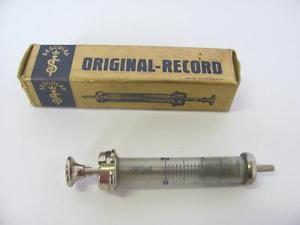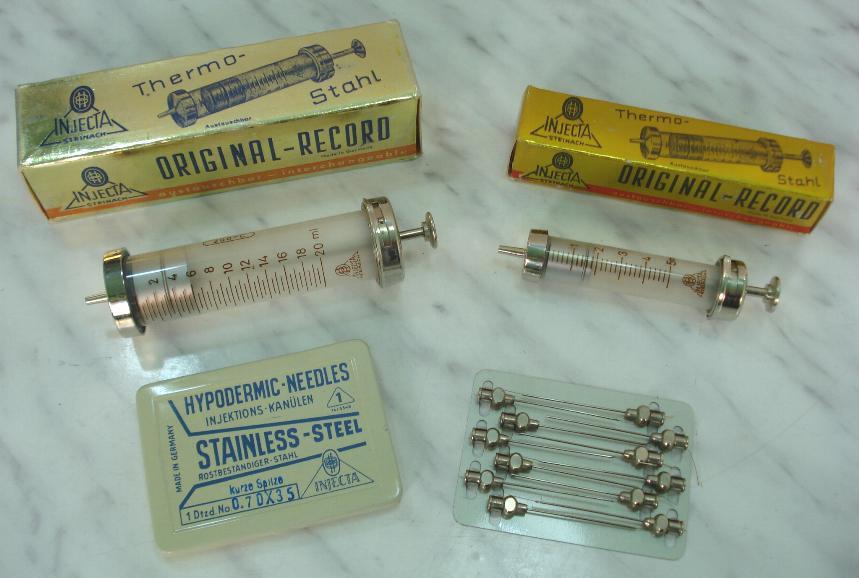The first image is the image on the left, the second image is the image on the right. Examine the images to the left and right. Is the description "There are no more than two syringes in total." accurate? Answer yes or no. No. The first image is the image on the left, the second image is the image on the right. Examine the images to the left and right. Is the description "there are at least 3 syringes" accurate? Answer yes or no. Yes. 